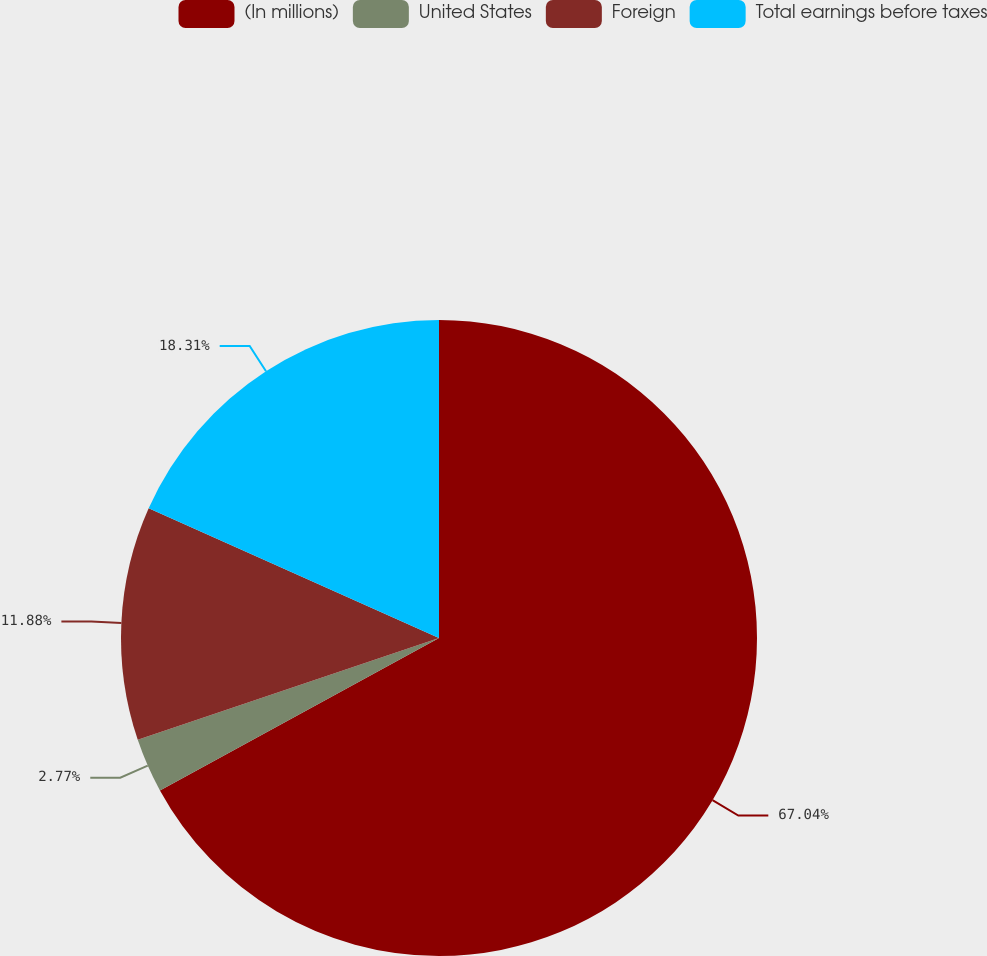Convert chart. <chart><loc_0><loc_0><loc_500><loc_500><pie_chart><fcel>(In millions)<fcel>United States<fcel>Foreign<fcel>Total earnings before taxes<nl><fcel>67.04%<fcel>2.77%<fcel>11.88%<fcel>18.31%<nl></chart> 